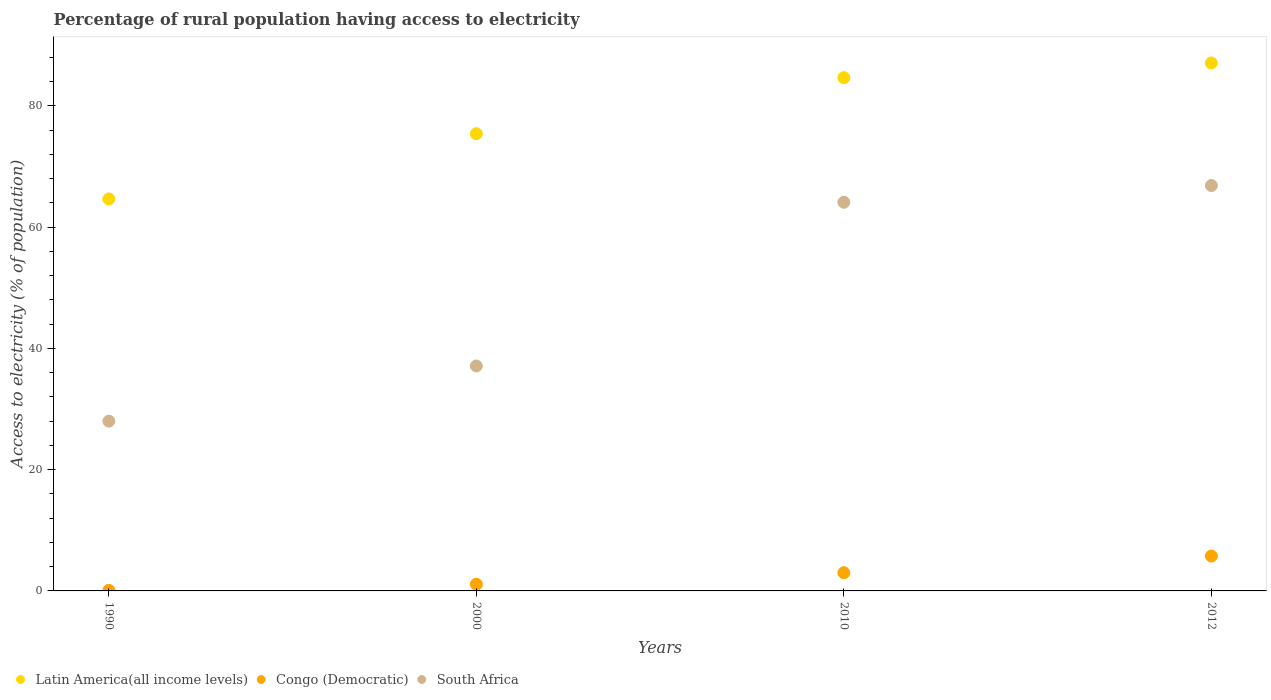What is the percentage of rural population having access to electricity in South Africa in 2012?
Make the answer very short. 66.85. Across all years, what is the maximum percentage of rural population having access to electricity in Latin America(all income levels)?
Keep it short and to the point. 87.07. Across all years, what is the minimum percentage of rural population having access to electricity in South Africa?
Your answer should be very brief. 28. What is the total percentage of rural population having access to electricity in Latin America(all income levels) in the graph?
Provide a short and direct response. 311.76. What is the difference between the percentage of rural population having access to electricity in Latin America(all income levels) in 1990 and that in 2012?
Provide a succinct answer. -22.43. What is the difference between the percentage of rural population having access to electricity in South Africa in 2012 and the percentage of rural population having access to electricity in Congo (Democratic) in 2010?
Provide a short and direct response. 63.85. What is the average percentage of rural population having access to electricity in Latin America(all income levels) per year?
Your response must be concise. 77.94. In the year 2000, what is the difference between the percentage of rural population having access to electricity in South Africa and percentage of rural population having access to electricity in Latin America(all income levels)?
Give a very brief answer. -38.3. In how many years, is the percentage of rural population having access to electricity in Congo (Democratic) greater than 16 %?
Your response must be concise. 0. What is the ratio of the percentage of rural population having access to electricity in Congo (Democratic) in 1990 to that in 2010?
Offer a very short reply. 0.03. Is the percentage of rural population having access to electricity in Latin America(all income levels) in 1990 less than that in 2000?
Make the answer very short. Yes. Is the difference between the percentage of rural population having access to electricity in South Africa in 1990 and 2012 greater than the difference between the percentage of rural population having access to electricity in Latin America(all income levels) in 1990 and 2012?
Offer a very short reply. No. What is the difference between the highest and the second highest percentage of rural population having access to electricity in South Africa?
Your answer should be compact. 2.75. What is the difference between the highest and the lowest percentage of rural population having access to electricity in Congo (Democratic)?
Your answer should be compact. 5.65. In how many years, is the percentage of rural population having access to electricity in South Africa greater than the average percentage of rural population having access to electricity in South Africa taken over all years?
Your answer should be compact. 2. Is the sum of the percentage of rural population having access to electricity in South Africa in 1990 and 2012 greater than the maximum percentage of rural population having access to electricity in Congo (Democratic) across all years?
Make the answer very short. Yes. Is the percentage of rural population having access to electricity in Latin America(all income levels) strictly less than the percentage of rural population having access to electricity in South Africa over the years?
Make the answer very short. No. What is the difference between two consecutive major ticks on the Y-axis?
Make the answer very short. 20. What is the title of the graph?
Make the answer very short. Percentage of rural population having access to electricity. What is the label or title of the Y-axis?
Your response must be concise. Access to electricity (% of population). What is the Access to electricity (% of population) in Latin America(all income levels) in 1990?
Offer a very short reply. 64.64. What is the Access to electricity (% of population) of South Africa in 1990?
Give a very brief answer. 28. What is the Access to electricity (% of population) in Latin America(all income levels) in 2000?
Provide a succinct answer. 75.4. What is the Access to electricity (% of population) of Congo (Democratic) in 2000?
Offer a terse response. 1.1. What is the Access to electricity (% of population) of South Africa in 2000?
Make the answer very short. 37.1. What is the Access to electricity (% of population) of Latin America(all income levels) in 2010?
Make the answer very short. 84.64. What is the Access to electricity (% of population) in Congo (Democratic) in 2010?
Make the answer very short. 3. What is the Access to electricity (% of population) in South Africa in 2010?
Offer a very short reply. 64.1. What is the Access to electricity (% of population) of Latin America(all income levels) in 2012?
Offer a terse response. 87.07. What is the Access to electricity (% of population) in Congo (Democratic) in 2012?
Provide a succinct answer. 5.75. What is the Access to electricity (% of population) in South Africa in 2012?
Offer a terse response. 66.85. Across all years, what is the maximum Access to electricity (% of population) in Latin America(all income levels)?
Offer a very short reply. 87.07. Across all years, what is the maximum Access to electricity (% of population) in Congo (Democratic)?
Provide a short and direct response. 5.75. Across all years, what is the maximum Access to electricity (% of population) of South Africa?
Your response must be concise. 66.85. Across all years, what is the minimum Access to electricity (% of population) of Latin America(all income levels)?
Provide a succinct answer. 64.64. What is the total Access to electricity (% of population) of Latin America(all income levels) in the graph?
Give a very brief answer. 311.76. What is the total Access to electricity (% of population) in Congo (Democratic) in the graph?
Offer a very short reply. 9.95. What is the total Access to electricity (% of population) in South Africa in the graph?
Provide a short and direct response. 196.05. What is the difference between the Access to electricity (% of population) in Latin America(all income levels) in 1990 and that in 2000?
Offer a terse response. -10.76. What is the difference between the Access to electricity (% of population) of Congo (Democratic) in 1990 and that in 2000?
Your answer should be very brief. -1. What is the difference between the Access to electricity (% of population) in Latin America(all income levels) in 1990 and that in 2010?
Your answer should be very brief. -20. What is the difference between the Access to electricity (% of population) in South Africa in 1990 and that in 2010?
Keep it short and to the point. -36.1. What is the difference between the Access to electricity (% of population) of Latin America(all income levels) in 1990 and that in 2012?
Offer a terse response. -22.43. What is the difference between the Access to electricity (% of population) in Congo (Democratic) in 1990 and that in 2012?
Your response must be concise. -5.65. What is the difference between the Access to electricity (% of population) of South Africa in 1990 and that in 2012?
Give a very brief answer. -38.85. What is the difference between the Access to electricity (% of population) in Latin America(all income levels) in 2000 and that in 2010?
Provide a short and direct response. -9.24. What is the difference between the Access to electricity (% of population) of Congo (Democratic) in 2000 and that in 2010?
Offer a very short reply. -1.9. What is the difference between the Access to electricity (% of population) of Latin America(all income levels) in 2000 and that in 2012?
Your answer should be very brief. -11.67. What is the difference between the Access to electricity (% of population) in Congo (Democratic) in 2000 and that in 2012?
Offer a terse response. -4.65. What is the difference between the Access to electricity (% of population) in South Africa in 2000 and that in 2012?
Offer a very short reply. -29.75. What is the difference between the Access to electricity (% of population) in Latin America(all income levels) in 2010 and that in 2012?
Your answer should be compact. -2.43. What is the difference between the Access to electricity (% of population) of Congo (Democratic) in 2010 and that in 2012?
Your response must be concise. -2.75. What is the difference between the Access to electricity (% of population) in South Africa in 2010 and that in 2012?
Offer a terse response. -2.75. What is the difference between the Access to electricity (% of population) of Latin America(all income levels) in 1990 and the Access to electricity (% of population) of Congo (Democratic) in 2000?
Your response must be concise. 63.54. What is the difference between the Access to electricity (% of population) of Latin America(all income levels) in 1990 and the Access to electricity (% of population) of South Africa in 2000?
Make the answer very short. 27.54. What is the difference between the Access to electricity (% of population) of Congo (Democratic) in 1990 and the Access to electricity (% of population) of South Africa in 2000?
Give a very brief answer. -37. What is the difference between the Access to electricity (% of population) of Latin America(all income levels) in 1990 and the Access to electricity (% of population) of Congo (Democratic) in 2010?
Provide a succinct answer. 61.64. What is the difference between the Access to electricity (% of population) in Latin America(all income levels) in 1990 and the Access to electricity (% of population) in South Africa in 2010?
Provide a short and direct response. 0.54. What is the difference between the Access to electricity (% of population) of Congo (Democratic) in 1990 and the Access to electricity (% of population) of South Africa in 2010?
Ensure brevity in your answer.  -64. What is the difference between the Access to electricity (% of population) in Latin America(all income levels) in 1990 and the Access to electricity (% of population) in Congo (Democratic) in 2012?
Keep it short and to the point. 58.89. What is the difference between the Access to electricity (% of population) in Latin America(all income levels) in 1990 and the Access to electricity (% of population) in South Africa in 2012?
Your response must be concise. -2.21. What is the difference between the Access to electricity (% of population) in Congo (Democratic) in 1990 and the Access to electricity (% of population) in South Africa in 2012?
Provide a short and direct response. -66.75. What is the difference between the Access to electricity (% of population) of Latin America(all income levels) in 2000 and the Access to electricity (% of population) of Congo (Democratic) in 2010?
Offer a very short reply. 72.4. What is the difference between the Access to electricity (% of population) in Latin America(all income levels) in 2000 and the Access to electricity (% of population) in South Africa in 2010?
Keep it short and to the point. 11.3. What is the difference between the Access to electricity (% of population) in Congo (Democratic) in 2000 and the Access to electricity (% of population) in South Africa in 2010?
Offer a terse response. -63. What is the difference between the Access to electricity (% of population) in Latin America(all income levels) in 2000 and the Access to electricity (% of population) in Congo (Democratic) in 2012?
Keep it short and to the point. 69.65. What is the difference between the Access to electricity (% of population) in Latin America(all income levels) in 2000 and the Access to electricity (% of population) in South Africa in 2012?
Provide a succinct answer. 8.55. What is the difference between the Access to electricity (% of population) of Congo (Democratic) in 2000 and the Access to electricity (% of population) of South Africa in 2012?
Provide a succinct answer. -65.75. What is the difference between the Access to electricity (% of population) in Latin America(all income levels) in 2010 and the Access to electricity (% of population) in Congo (Democratic) in 2012?
Give a very brief answer. 78.89. What is the difference between the Access to electricity (% of population) of Latin America(all income levels) in 2010 and the Access to electricity (% of population) of South Africa in 2012?
Provide a succinct answer. 17.79. What is the difference between the Access to electricity (% of population) in Congo (Democratic) in 2010 and the Access to electricity (% of population) in South Africa in 2012?
Ensure brevity in your answer.  -63.85. What is the average Access to electricity (% of population) of Latin America(all income levels) per year?
Keep it short and to the point. 77.94. What is the average Access to electricity (% of population) in Congo (Democratic) per year?
Your answer should be compact. 2.49. What is the average Access to electricity (% of population) in South Africa per year?
Your response must be concise. 49.01. In the year 1990, what is the difference between the Access to electricity (% of population) of Latin America(all income levels) and Access to electricity (% of population) of Congo (Democratic)?
Ensure brevity in your answer.  64.54. In the year 1990, what is the difference between the Access to electricity (% of population) of Latin America(all income levels) and Access to electricity (% of population) of South Africa?
Provide a short and direct response. 36.64. In the year 1990, what is the difference between the Access to electricity (% of population) of Congo (Democratic) and Access to electricity (% of population) of South Africa?
Ensure brevity in your answer.  -27.9. In the year 2000, what is the difference between the Access to electricity (% of population) of Latin America(all income levels) and Access to electricity (% of population) of Congo (Democratic)?
Offer a very short reply. 74.3. In the year 2000, what is the difference between the Access to electricity (% of population) of Latin America(all income levels) and Access to electricity (% of population) of South Africa?
Offer a very short reply. 38.3. In the year 2000, what is the difference between the Access to electricity (% of population) in Congo (Democratic) and Access to electricity (% of population) in South Africa?
Provide a short and direct response. -36. In the year 2010, what is the difference between the Access to electricity (% of population) of Latin America(all income levels) and Access to electricity (% of population) of Congo (Democratic)?
Provide a succinct answer. 81.64. In the year 2010, what is the difference between the Access to electricity (% of population) in Latin America(all income levels) and Access to electricity (% of population) in South Africa?
Your answer should be very brief. 20.54. In the year 2010, what is the difference between the Access to electricity (% of population) in Congo (Democratic) and Access to electricity (% of population) in South Africa?
Provide a short and direct response. -61.1. In the year 2012, what is the difference between the Access to electricity (% of population) of Latin America(all income levels) and Access to electricity (% of population) of Congo (Democratic)?
Provide a short and direct response. 81.32. In the year 2012, what is the difference between the Access to electricity (% of population) in Latin America(all income levels) and Access to electricity (% of population) in South Africa?
Ensure brevity in your answer.  20.22. In the year 2012, what is the difference between the Access to electricity (% of population) of Congo (Democratic) and Access to electricity (% of population) of South Africa?
Provide a succinct answer. -61.1. What is the ratio of the Access to electricity (% of population) in Latin America(all income levels) in 1990 to that in 2000?
Ensure brevity in your answer.  0.86. What is the ratio of the Access to electricity (% of population) of Congo (Democratic) in 1990 to that in 2000?
Your answer should be very brief. 0.09. What is the ratio of the Access to electricity (% of population) of South Africa in 1990 to that in 2000?
Ensure brevity in your answer.  0.75. What is the ratio of the Access to electricity (% of population) in Latin America(all income levels) in 1990 to that in 2010?
Make the answer very short. 0.76. What is the ratio of the Access to electricity (% of population) in Congo (Democratic) in 1990 to that in 2010?
Your response must be concise. 0.03. What is the ratio of the Access to electricity (% of population) in South Africa in 1990 to that in 2010?
Provide a short and direct response. 0.44. What is the ratio of the Access to electricity (% of population) of Latin America(all income levels) in 1990 to that in 2012?
Your answer should be compact. 0.74. What is the ratio of the Access to electricity (% of population) of Congo (Democratic) in 1990 to that in 2012?
Ensure brevity in your answer.  0.02. What is the ratio of the Access to electricity (% of population) of South Africa in 1990 to that in 2012?
Your answer should be compact. 0.42. What is the ratio of the Access to electricity (% of population) in Latin America(all income levels) in 2000 to that in 2010?
Make the answer very short. 0.89. What is the ratio of the Access to electricity (% of population) in Congo (Democratic) in 2000 to that in 2010?
Offer a very short reply. 0.37. What is the ratio of the Access to electricity (% of population) of South Africa in 2000 to that in 2010?
Keep it short and to the point. 0.58. What is the ratio of the Access to electricity (% of population) of Latin America(all income levels) in 2000 to that in 2012?
Offer a terse response. 0.87. What is the ratio of the Access to electricity (% of population) in Congo (Democratic) in 2000 to that in 2012?
Provide a short and direct response. 0.19. What is the ratio of the Access to electricity (% of population) of South Africa in 2000 to that in 2012?
Ensure brevity in your answer.  0.55. What is the ratio of the Access to electricity (% of population) of Latin America(all income levels) in 2010 to that in 2012?
Provide a short and direct response. 0.97. What is the ratio of the Access to electricity (% of population) in Congo (Democratic) in 2010 to that in 2012?
Keep it short and to the point. 0.52. What is the ratio of the Access to electricity (% of population) in South Africa in 2010 to that in 2012?
Your response must be concise. 0.96. What is the difference between the highest and the second highest Access to electricity (% of population) of Latin America(all income levels)?
Provide a succinct answer. 2.43. What is the difference between the highest and the second highest Access to electricity (% of population) in Congo (Democratic)?
Your answer should be compact. 2.75. What is the difference between the highest and the second highest Access to electricity (% of population) of South Africa?
Keep it short and to the point. 2.75. What is the difference between the highest and the lowest Access to electricity (% of population) in Latin America(all income levels)?
Provide a succinct answer. 22.43. What is the difference between the highest and the lowest Access to electricity (% of population) of Congo (Democratic)?
Your answer should be very brief. 5.65. What is the difference between the highest and the lowest Access to electricity (% of population) of South Africa?
Offer a very short reply. 38.85. 